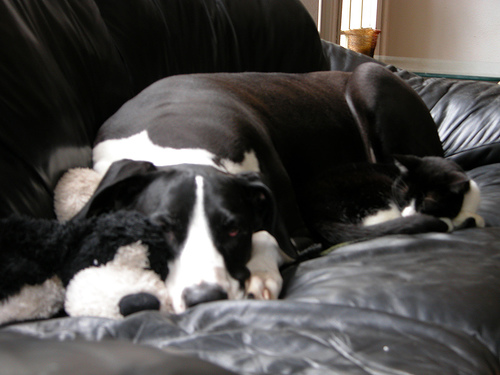Can you tell me what kind of dog that might be? Considering its size and black-and-white coloring, the dog could possibly be a Great Dane or a similarly large breed known for their gentle nature, which complements the image's peaceful theme. Are you sure about the breed? Without a clear view of more distinctive features, it's difficult to determine the exact breed with certainty. However, the dog's physical traits do align with characteristics commonly seen in larger breeds like Great Danes. 